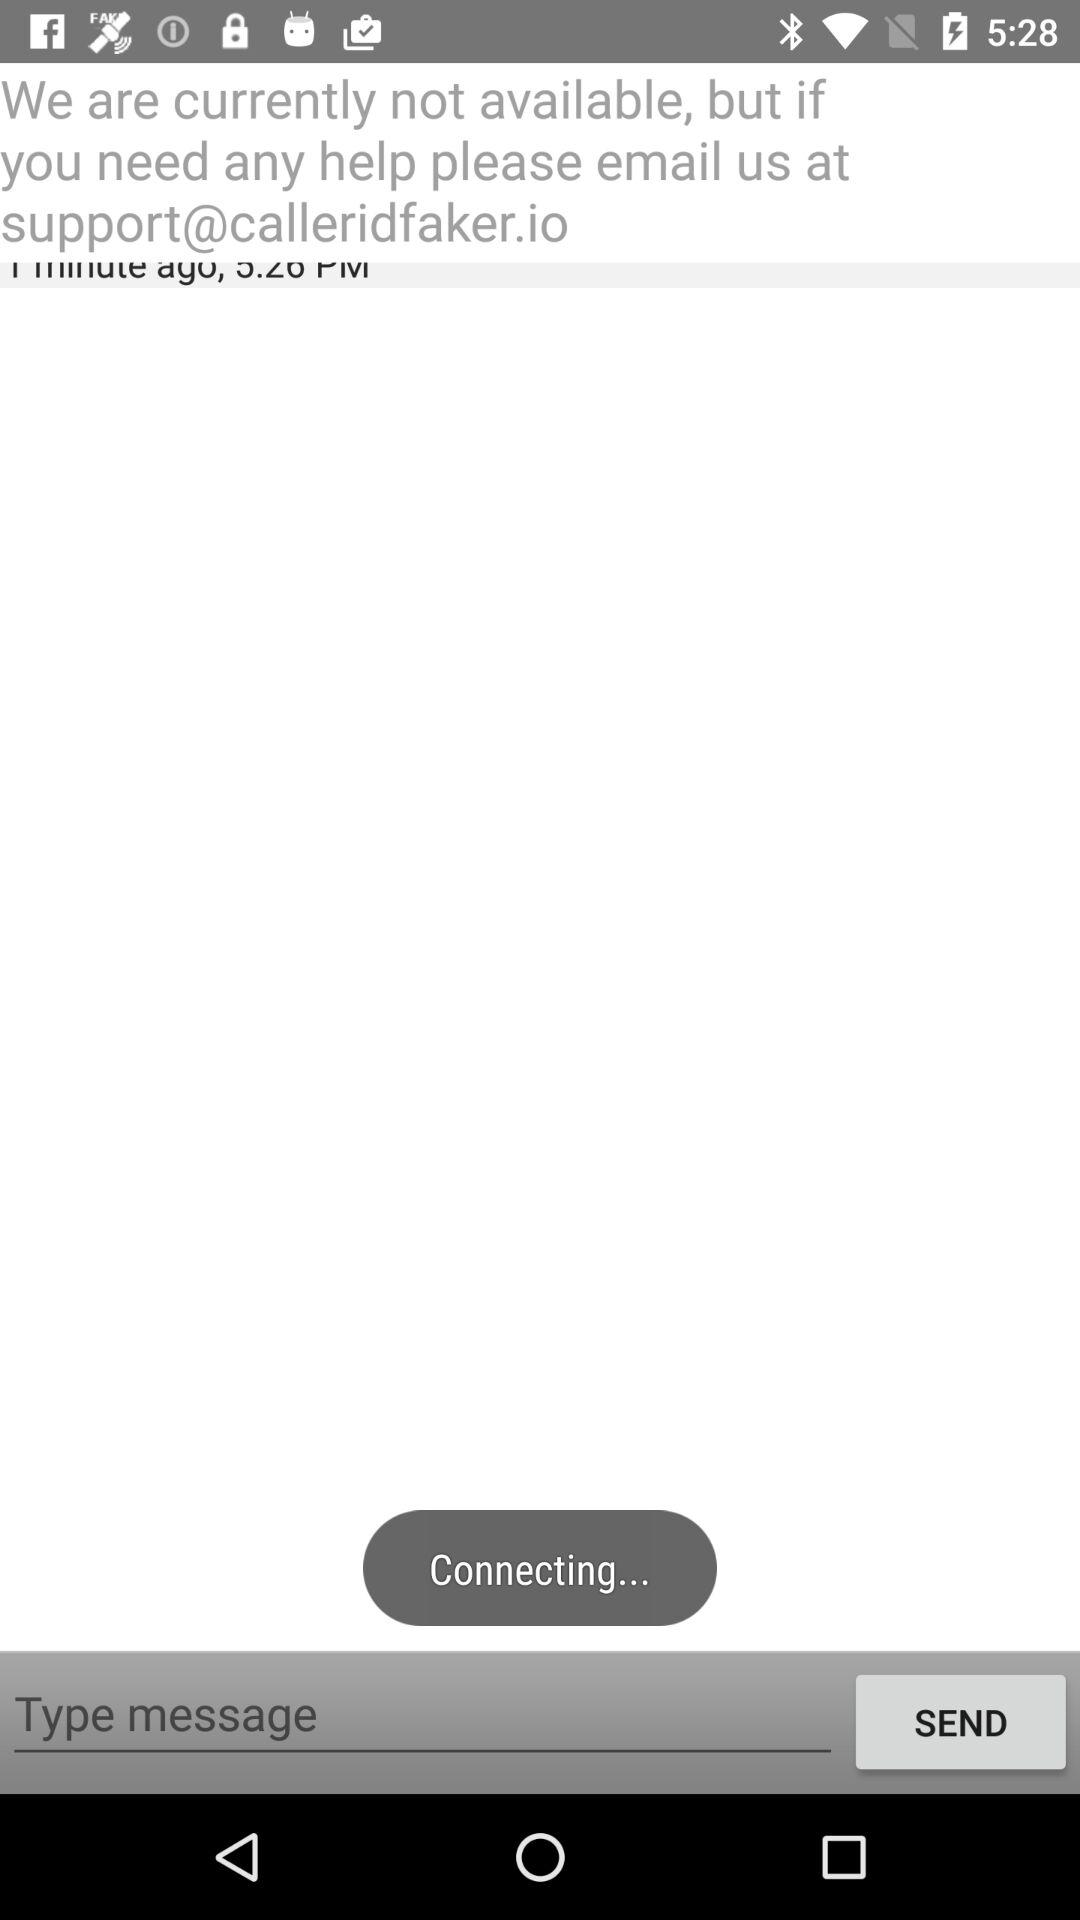What is the email address? The email address is support@calleridfaker.io. 